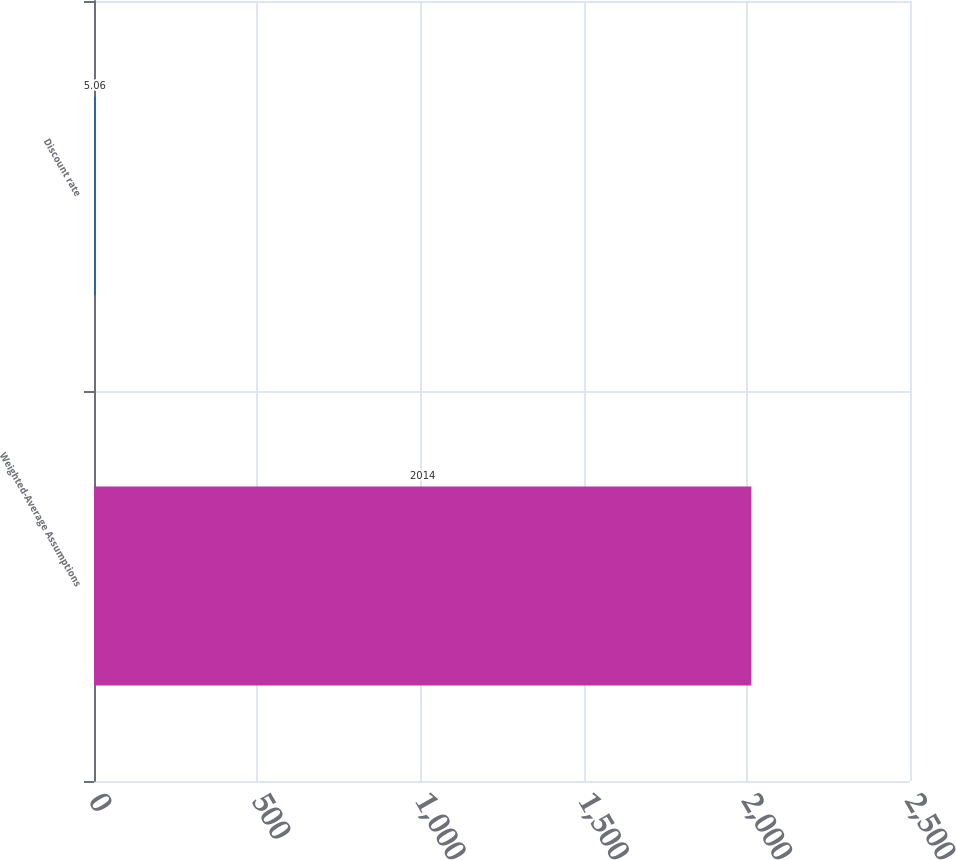Convert chart. <chart><loc_0><loc_0><loc_500><loc_500><bar_chart><fcel>Weighted-Average Assumptions<fcel>Discount rate<nl><fcel>2014<fcel>5.06<nl></chart> 